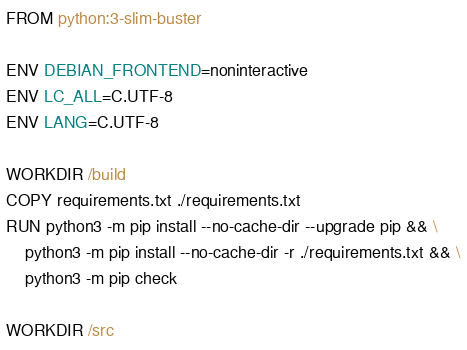Convert code to text. <code><loc_0><loc_0><loc_500><loc_500><_Dockerfile_>FROM python:3-slim-buster

ENV DEBIAN_FRONTEND=noninteractive
ENV LC_ALL=C.UTF-8
ENV LANG=C.UTF-8

WORKDIR /build
COPY requirements.txt ./requirements.txt
RUN python3 -m pip install --no-cache-dir --upgrade pip && \
    python3 -m pip install --no-cache-dir -r ./requirements.txt && \
    python3 -m pip check

WORKDIR /src
</code> 